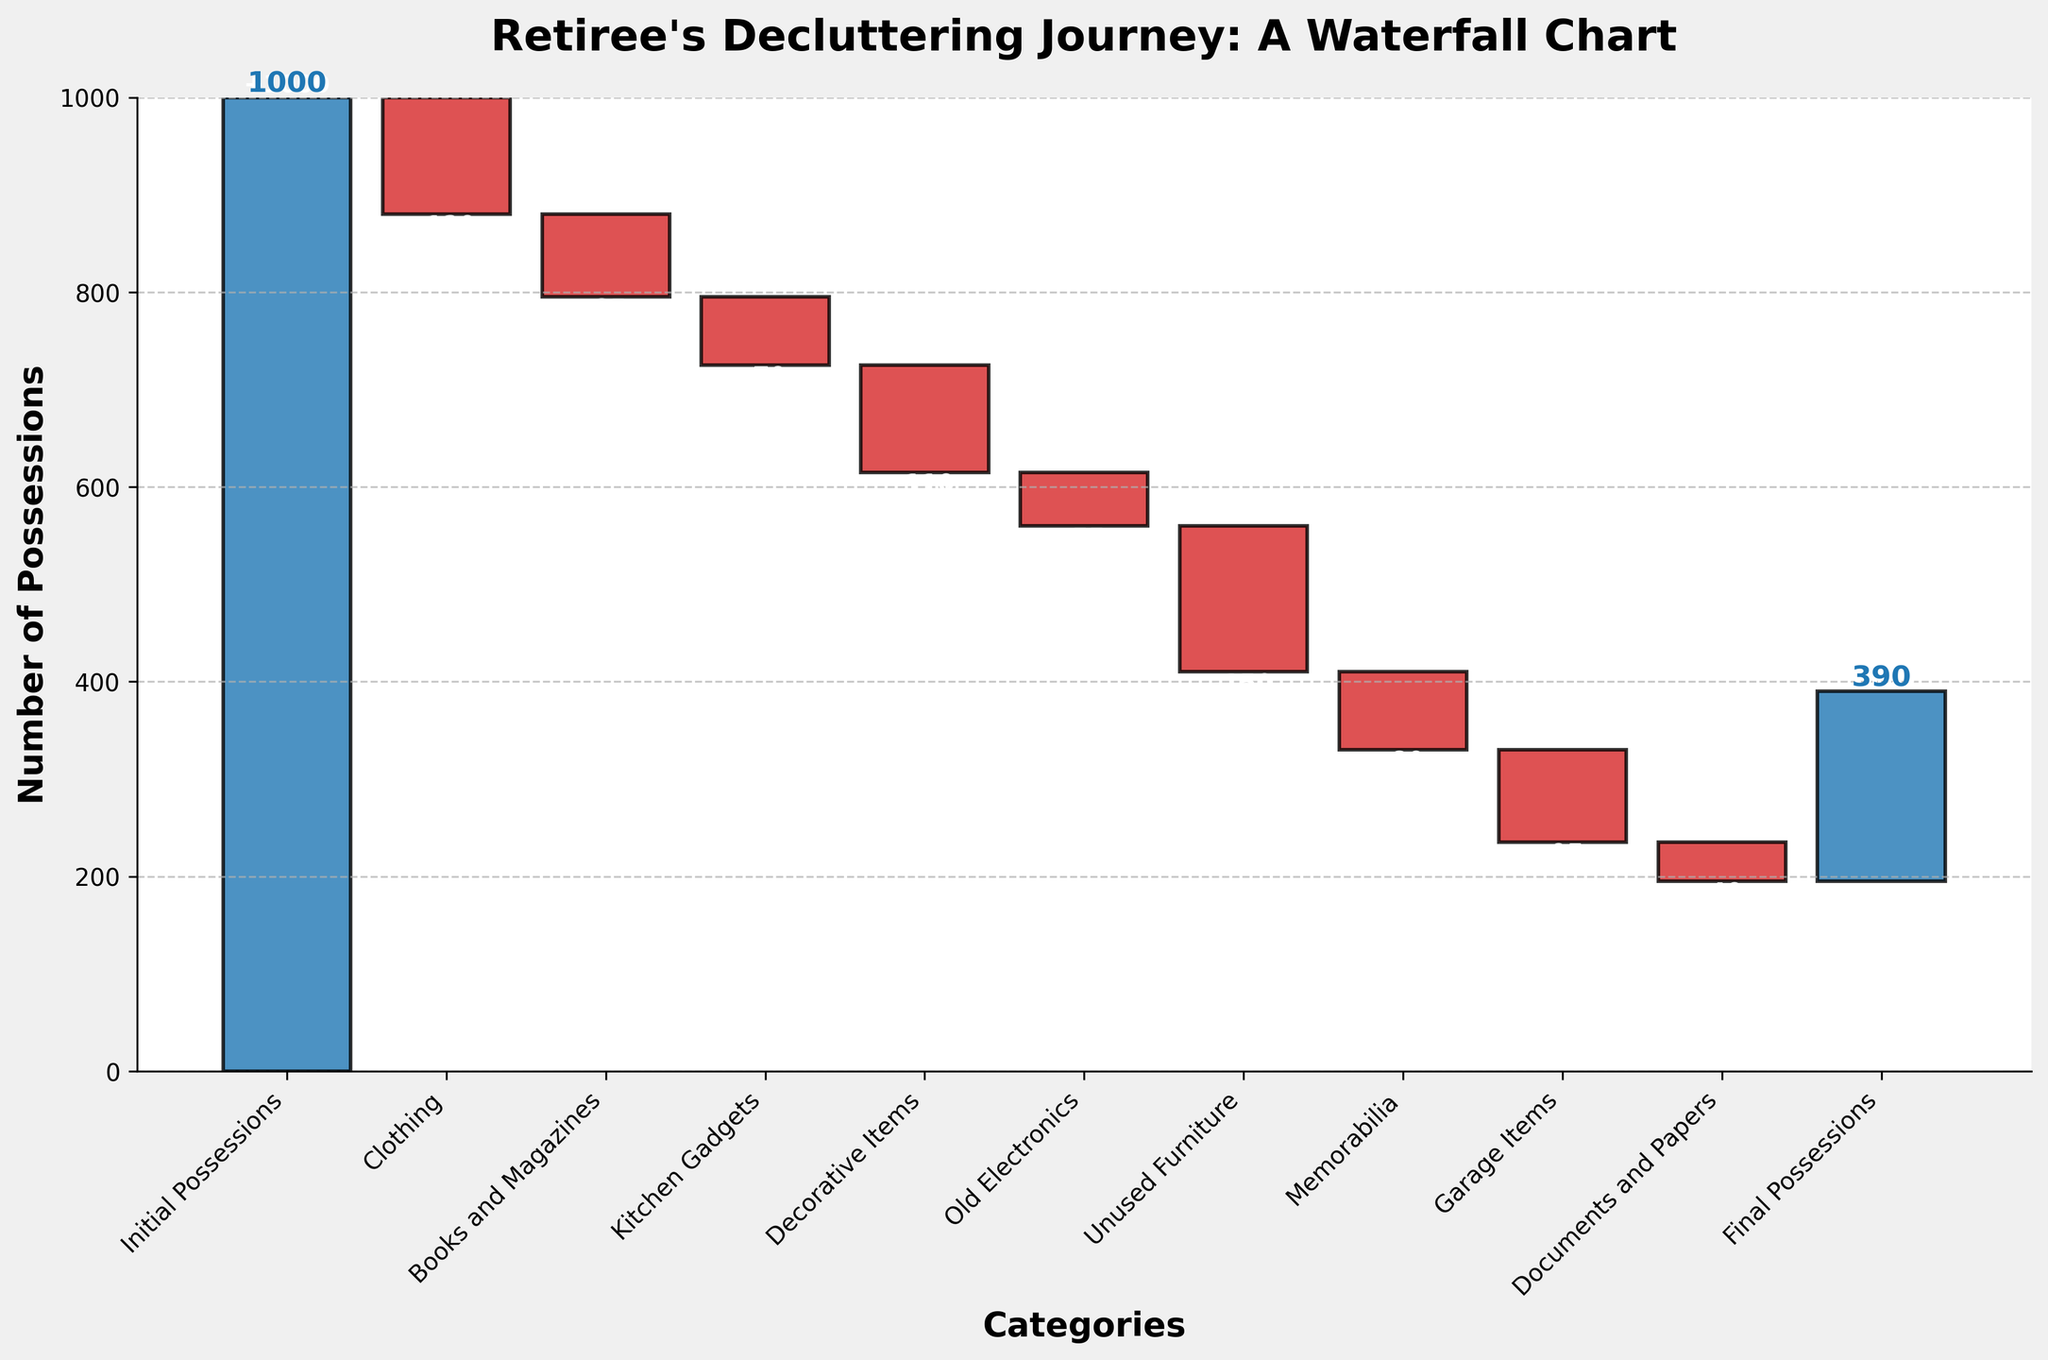How many categories are there in the chart? The chart shows various possessions broken down into categories. By counting all the labels on the x-axis, starting from "Initial Possessions" to "Final Possessions," we identify there are 11 categories.
Answer: 11 What is the title of the chart? The title of the chart is displayed at the top in bold, stating "Retiree's Decluttering Journey: A Waterfall Chart."
Answer: Retiree's Decluttering Journey: A Waterfall Chart Which category had the largest reduction in possessions? To find the category with the largest reduction, we need to compare the negative values on the y-axis. "Unused Furniture" has the greatest bar length in the negative direction at -150.
Answer: Unused Furniture What is the value of possessions after decluttering "Documents and Papers"? After "Documents and Papers," the cumulative possessions bar value is shown. Cumulative value after reducing by -40 gives a result of 240 - 40 = 200.
Answer: 200 What is the initial number of possessions? The initial number of possessions is labeled at the start, showing 1000 possessions.
Answer: 1000 Which decluttered category is closest in value to "Old Electronics"? By comparing the lengths of the bars for the negative values indicated, "Documents and Papers" at -40 is the closest to "Old Electronics" at -55.
Answer: Documents and Papers How many possessions were reduced collectively from "Books and Magazines," "Kitchen Gadgets," and "Decorative Items"? Summing the values from these three categories: -85 (Books and Magazines) + -70 (Kitchen Gadgets) + -110 (Decorative Items) gives a total reduction of -265.
Answer: -265 What is the middle cumulative value shown in the chart? To find the median cumulative value, we need to order the cumulative values calculated and find the middle one. The cumulative values are [1000, 880, 795, 725, 615, 560, 410, 330, 195, 195]. The middle value when sorted is between 615 and 560, so the median is (615+560)/2 = 587.5.
Answer: 587.5 How many possessions are left after reducing "Unused Furniture"? The cumulative value after "Unused Furniture" is shown as 410 possessions. This is observed right after its bar.
Answer: 410 What is the cumulative reduction in the number of possessions from the beginning to the end? The difference between the initial and final values gives the total reduction. Initial is 1000 and final is 195, so 1000 - 195 = 805.
Answer: 805 